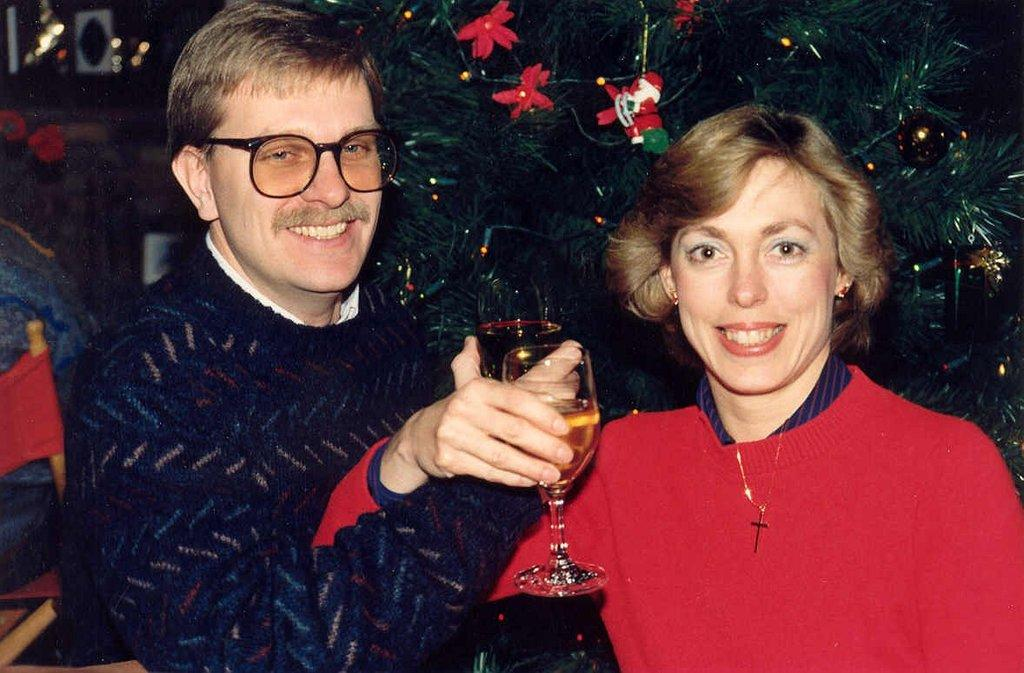Who is present in the image? There is a couple in the image. What are the couple holding in their hands? The couple is holding a glass of wine in their hands. What is the couple's facial expression? The couple is smiling. What can be seen in the background of the image? There is a Christmas tree in the background of the image. What type of kite is the couple discussing in the image? There is no kite present in the image, nor is there any discussion about a kite. 